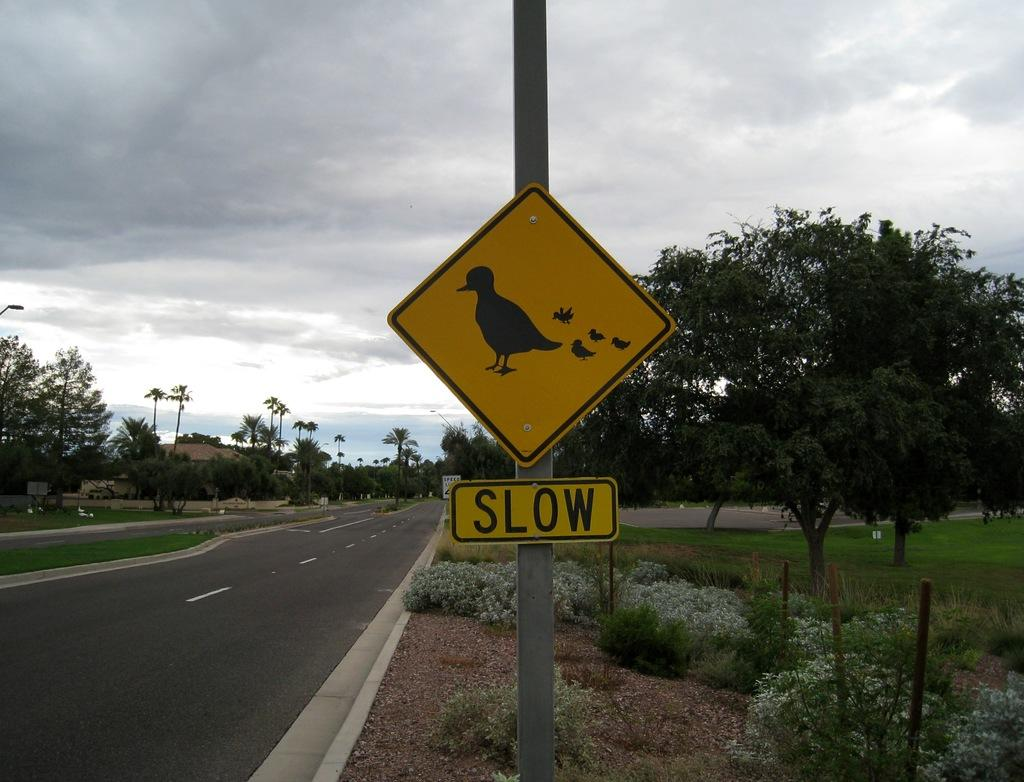<image>
Share a concise interpretation of the image provided. A Slow sign is beneath a sign with a pciture of a bird and chicks. 